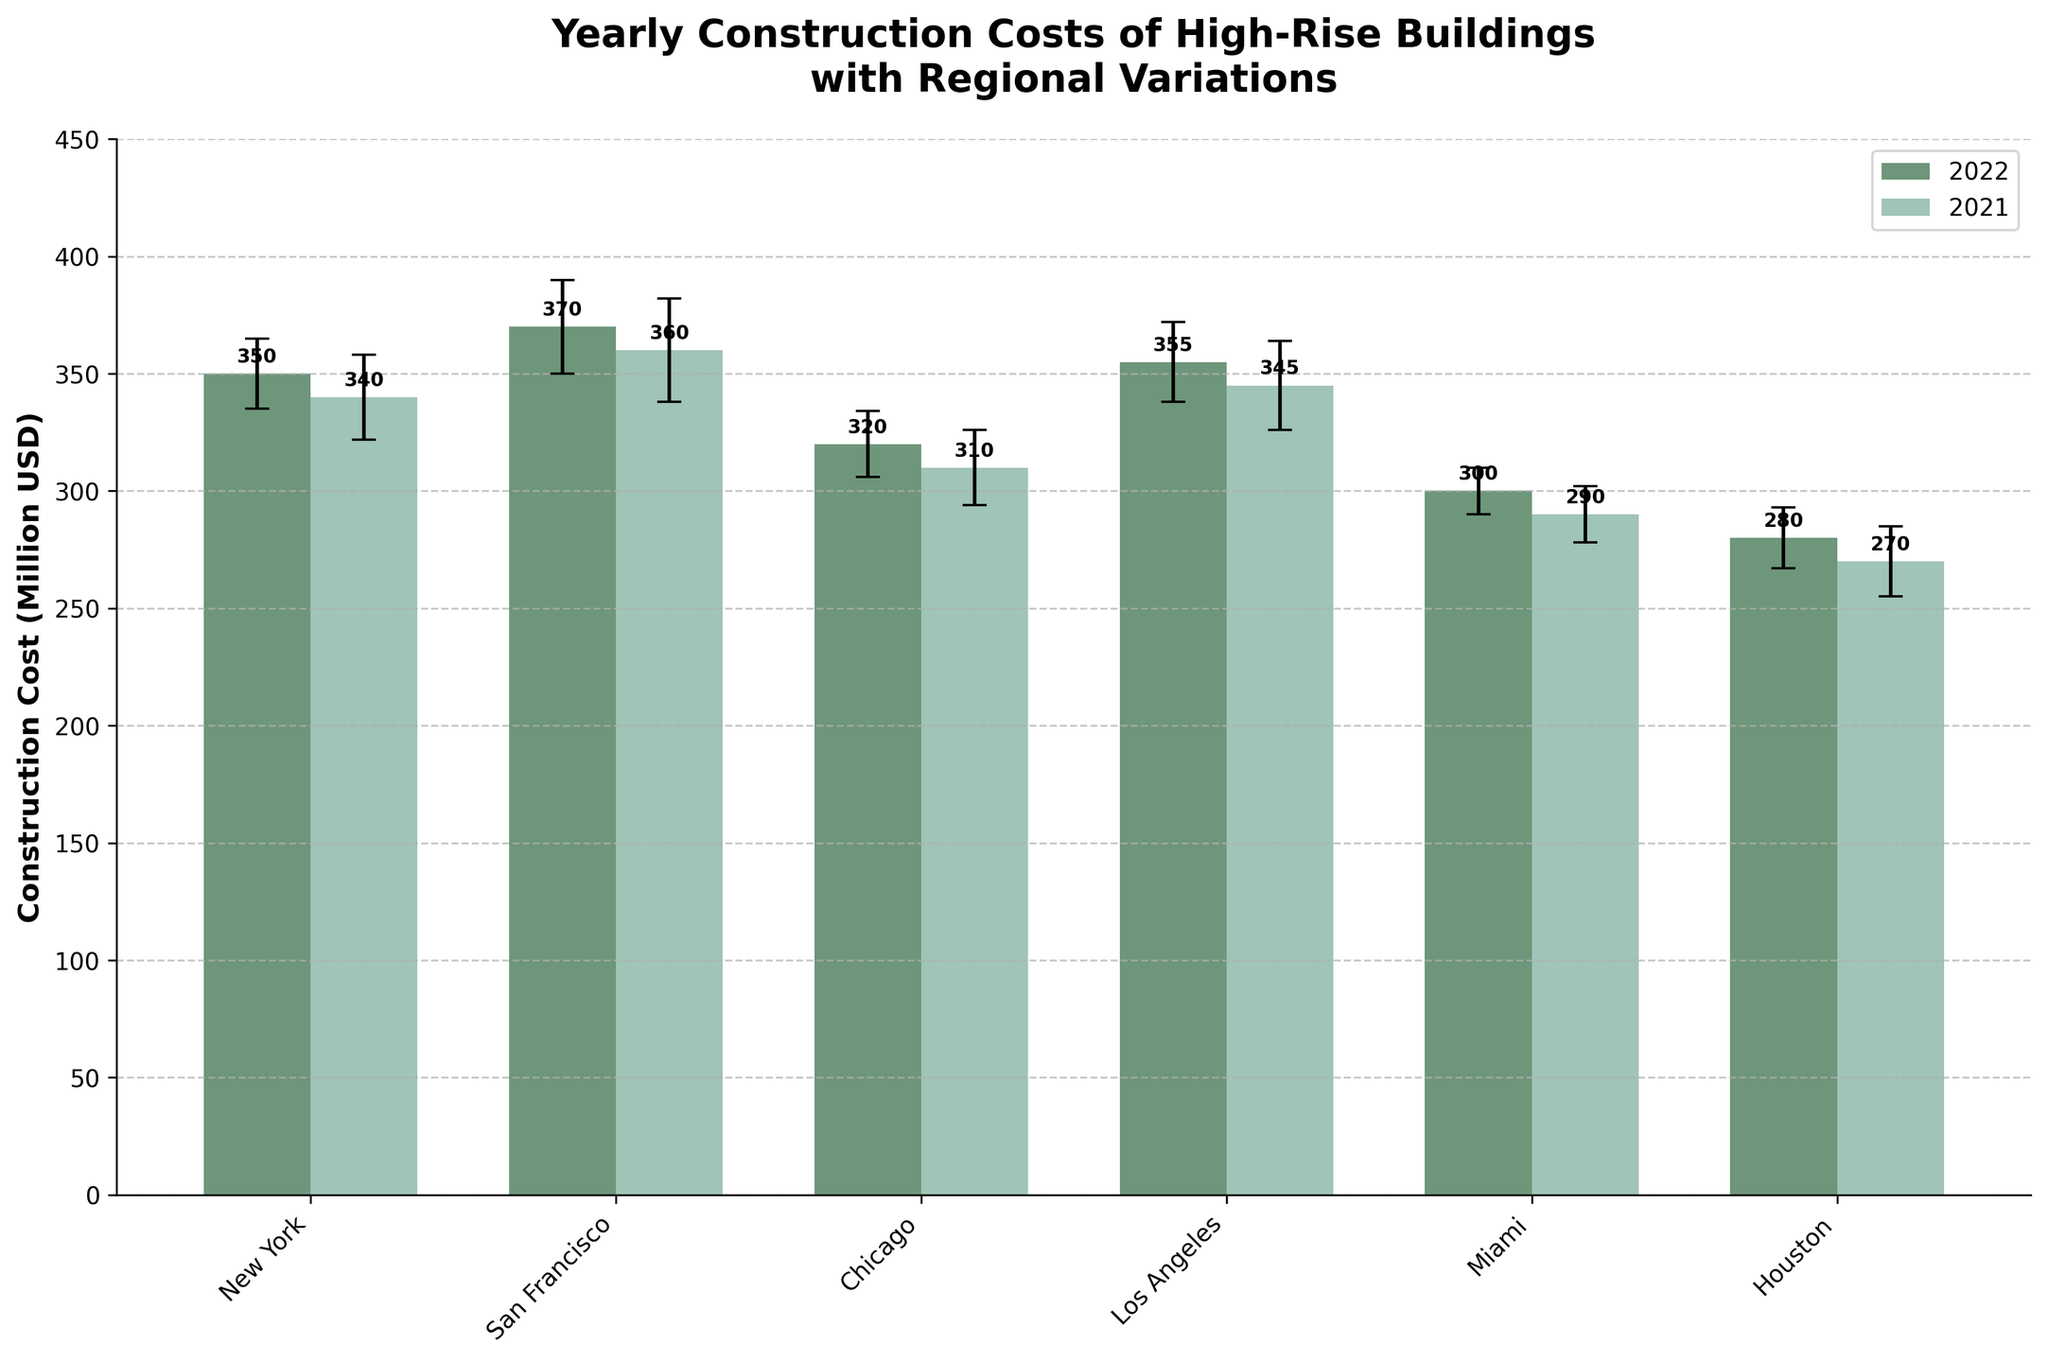what is the title of the chart? The title of the chart can be found at the top and states the subject the visualization is about.
Answer: Yearly Construction Costs of High-Rise Buildings with Regional Variations which region had the highest construction cost in 2022? The highest bar in the 2022 group represents the highest construction cost for that year.
Answer: San Francisco what is the construction cost difference between New York and Miami in 2021? Look at the bars for New York and Miami in the 2021 group and subtract the construction cost of Miami from that of New York: 340 - 290 = 50.
Answer: 50 million USD how much did construction costs change in Chicago from 2021 to 2022? Check the heights of the bars for Chicago for both years and calculate the difference: 320 - 310 = 10.
Answer: increased by 10 million USD which city had the least variance in construction costs between 2021 and 2022? Variance in costs is observed by seeing which cities have the smallest difference between the two bars for each year. Houston shows the least difference with 270 in 2021 and 280 in 2022.
Answer: Houston what is the range of construction costs for New York over both years? The range is found by subtracting the lowest cost value from the highest cost value in New York: 350 - 340 = 10.
Answer: 10 million USD which year had higher overall construction costs in Los Angeles? Compare the heights of the 2021 and 2022 bars for Los Angeles. In both cases, 355 in 2022 is slightly higher than 345 in 2021.
Answer: 2022 how do the error bars in Miami compare to those in San Francisco for 2022? Observation of the length of the error bars shows that San Francisco has longer bars (20) compared to Miami (10).
Answer: San Francisco has larger error bars what's the construction cost difference between the city with the highest cost and the city with the lowest cost in 2022? Identify the city with the highest cost (San Francisco, 370) and the city with the lowest cost (Houston, 280) in 2022, and subtract them: 370 - 280 = 90.
Answer: 90 million USD 